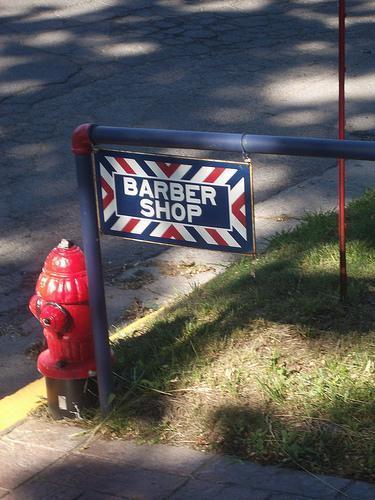How many fire hydrants are there?
Give a very brief answer. 1. 